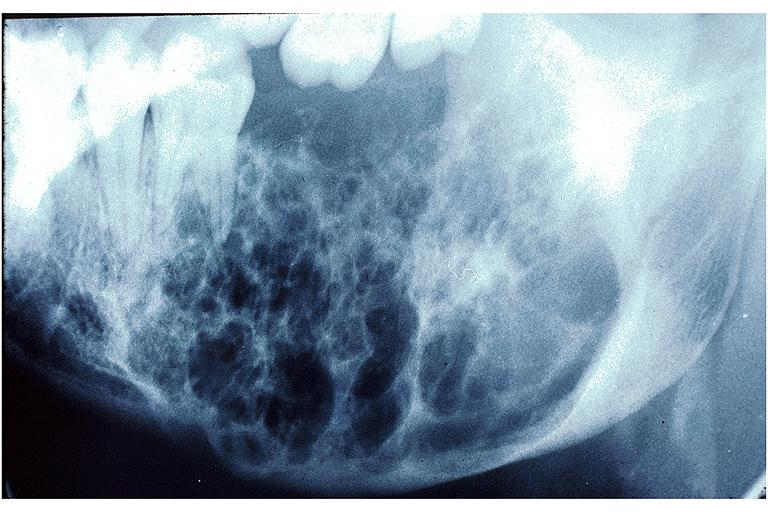s oral present?
Answer the question using a single word or phrase. Yes 